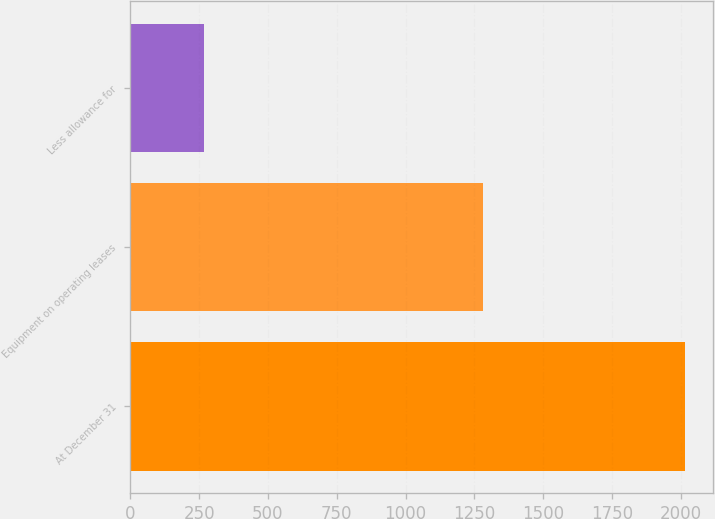Convert chart to OTSL. <chart><loc_0><loc_0><loc_500><loc_500><bar_chart><fcel>At December 31<fcel>Equipment on operating leases<fcel>Less allowance for<nl><fcel>2016<fcel>1282.3<fcel>268.4<nl></chart> 